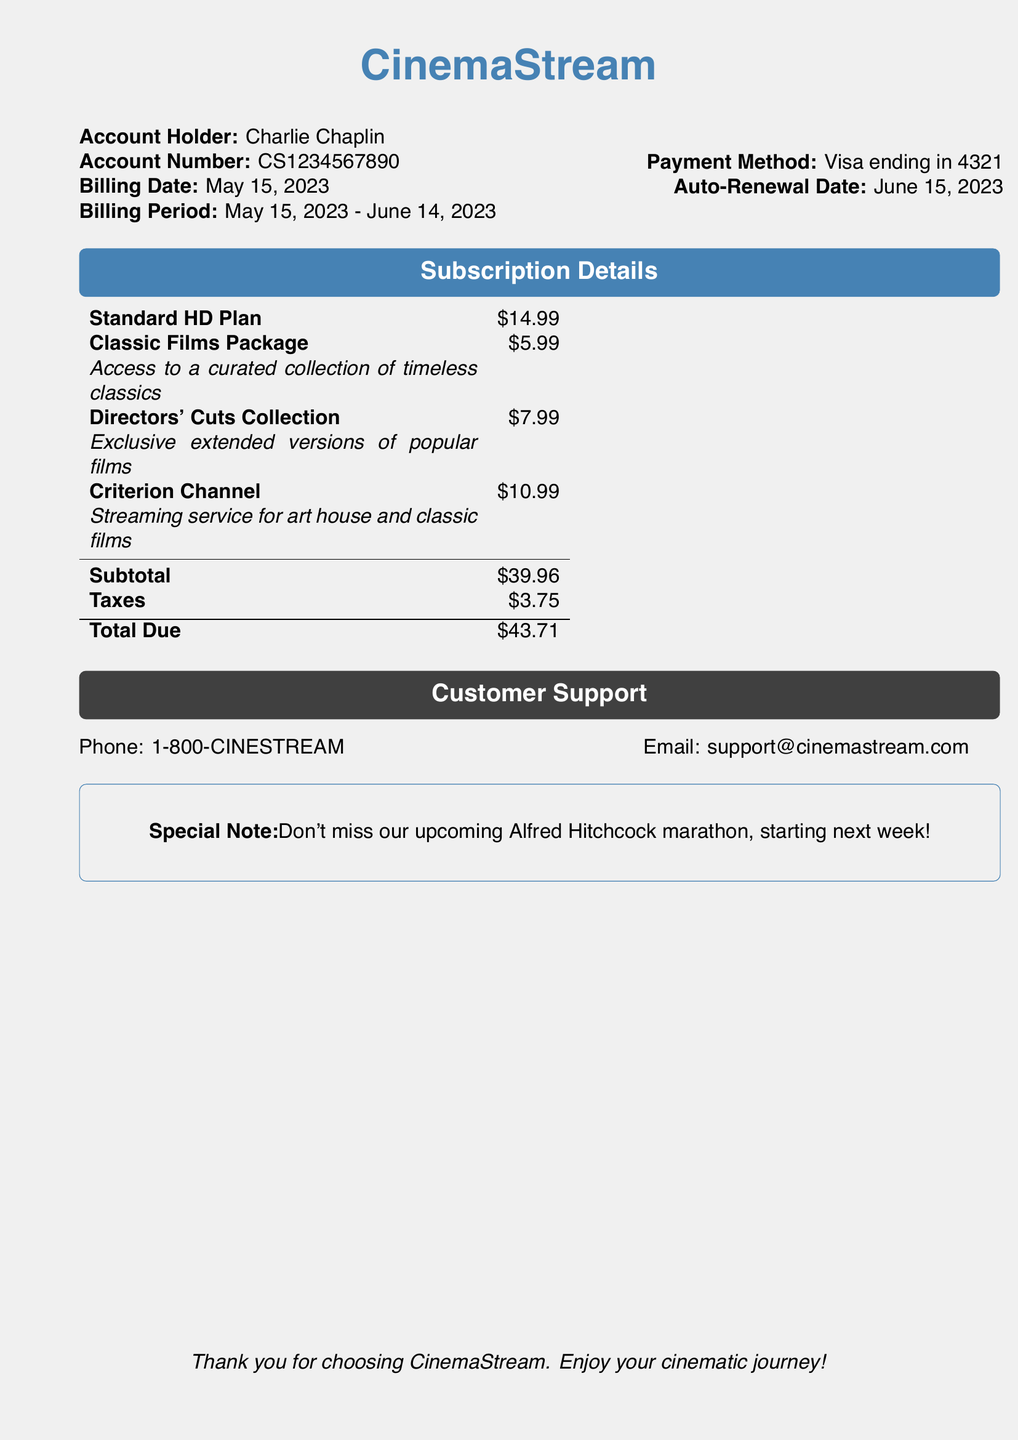What is the account holder's name? The account holder's name is listed near the top of the document.
Answer: Charlie Chaplin What is the total amount due? The total amount due is clearly stated in the summary section of the bill.
Answer: $43.71 What is the billing date? The billing date is displayed in the account information section.
Answer: May 15, 2023 How much is the Classic Films Package? The price for the Classic Films Package is provided in the subscription details.
Answer: $5.99 What is the auto-renewal date? The auto-renewal date can be found in the payment information.
Answer: June 15, 2023 Which plan is priced at $14.99? The plan priced at $14.99 is specified in the subscription details.
Answer: Standard HD Plan What will you receive with the Directors' Cuts Collection? A description of what to expect from the Directors' Cuts Collection is provided in the bill.
Answer: Exclusive extended versions of popular films What is the subtotal before taxes? The subtotal before taxes is indicated in the billing summary section.
Answer: $39.96 What method of payment is used? The payment method is mentioned in the account information section of the bill.
Answer: Visa ending in 4321 